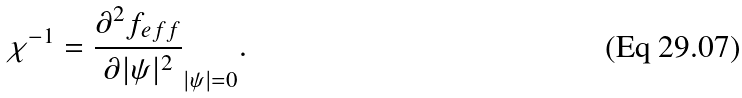Convert formula to latex. <formula><loc_0><loc_0><loc_500><loc_500>\chi ^ { - 1 } = \frac { \partial ^ { 2 } f _ { e f f } } { \partial | \psi | ^ { 2 } } _ { | \psi | = 0 } .</formula> 